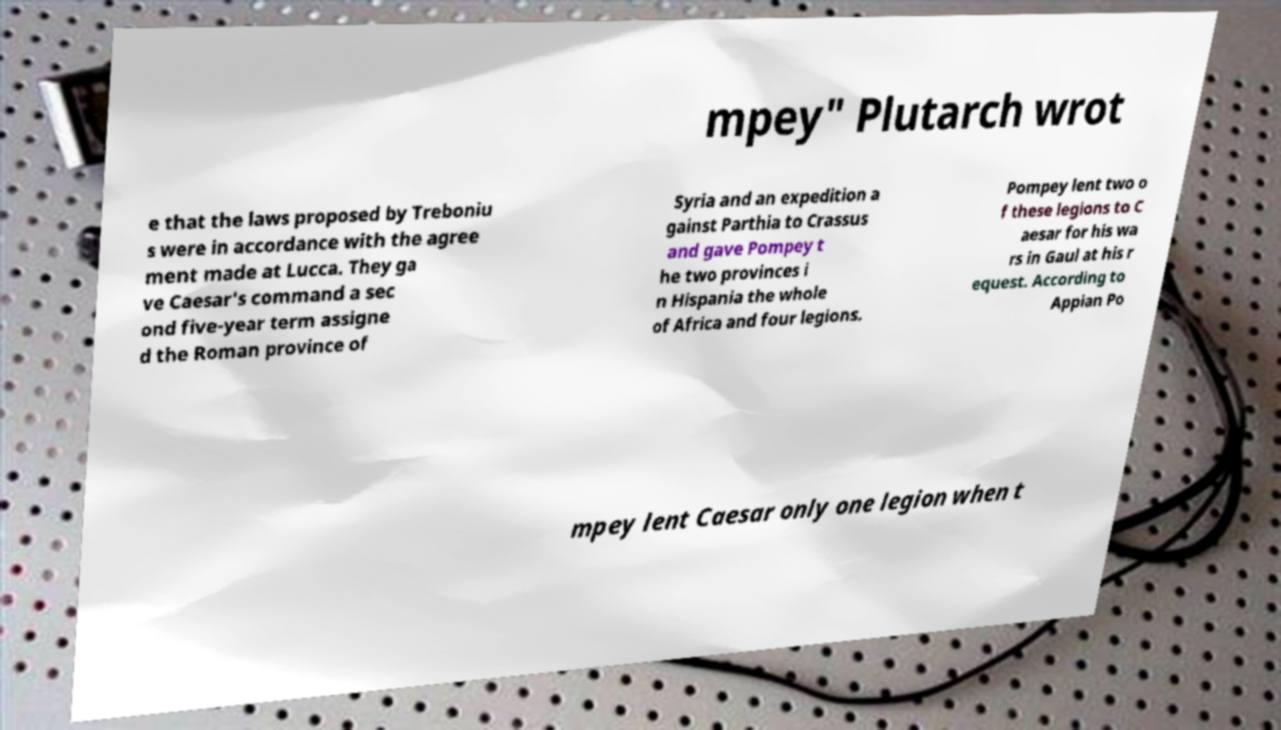What messages or text are displayed in this image? I need them in a readable, typed format. mpey" Plutarch wrot e that the laws proposed by Treboniu s were in accordance with the agree ment made at Lucca. They ga ve Caesar's command a sec ond five-year term assigne d the Roman province of Syria and an expedition a gainst Parthia to Crassus and gave Pompey t he two provinces i n Hispania the whole of Africa and four legions. Pompey lent two o f these legions to C aesar for his wa rs in Gaul at his r equest. According to Appian Po mpey lent Caesar only one legion when t 